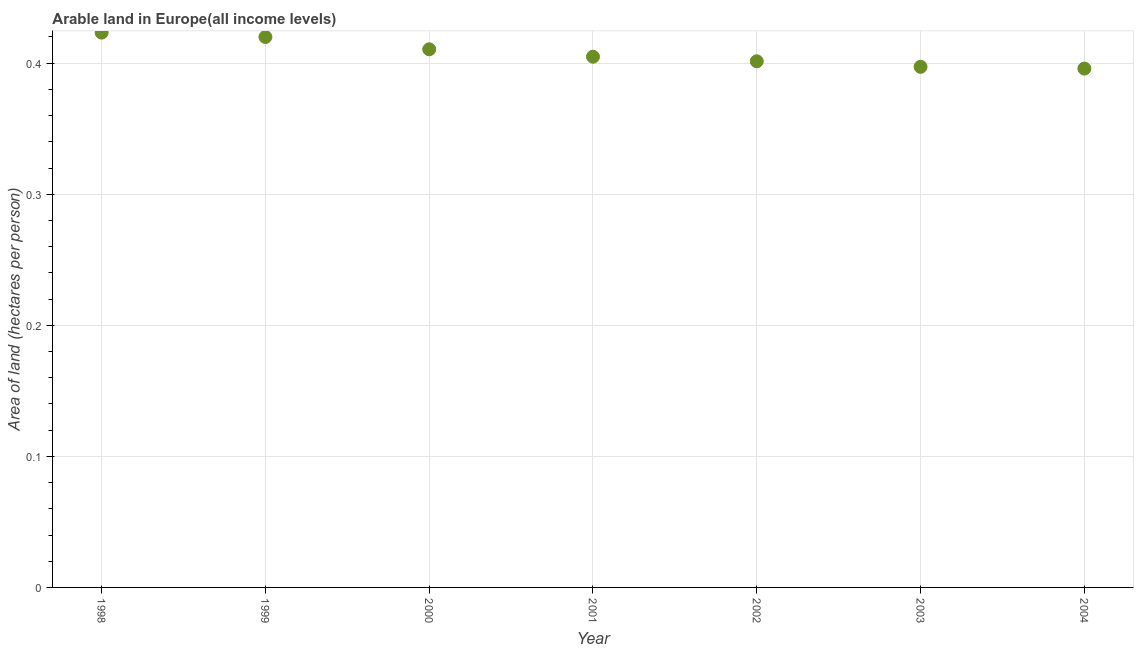What is the area of arable land in 2003?
Provide a succinct answer. 0.4. Across all years, what is the maximum area of arable land?
Keep it short and to the point. 0.42. Across all years, what is the minimum area of arable land?
Provide a short and direct response. 0.4. In which year was the area of arable land maximum?
Offer a terse response. 1998. What is the sum of the area of arable land?
Provide a short and direct response. 2.85. What is the difference between the area of arable land in 1998 and 2001?
Provide a succinct answer. 0.02. What is the average area of arable land per year?
Keep it short and to the point. 0.41. What is the median area of arable land?
Offer a terse response. 0.4. In how many years, is the area of arable land greater than 0.36000000000000004 hectares per person?
Offer a very short reply. 7. Do a majority of the years between 1999 and 2000 (inclusive) have area of arable land greater than 0.36000000000000004 hectares per person?
Make the answer very short. Yes. What is the ratio of the area of arable land in 1999 to that in 2000?
Ensure brevity in your answer.  1.02. Is the difference between the area of arable land in 2001 and 2004 greater than the difference between any two years?
Your answer should be compact. No. What is the difference between the highest and the second highest area of arable land?
Offer a terse response. 0. Is the sum of the area of arable land in 1999 and 2000 greater than the maximum area of arable land across all years?
Give a very brief answer. Yes. What is the difference between the highest and the lowest area of arable land?
Your response must be concise. 0.03. In how many years, is the area of arable land greater than the average area of arable land taken over all years?
Ensure brevity in your answer.  3. Does the area of arable land monotonically increase over the years?
Your response must be concise. No. What is the difference between two consecutive major ticks on the Y-axis?
Provide a succinct answer. 0.1. Are the values on the major ticks of Y-axis written in scientific E-notation?
Provide a succinct answer. No. Does the graph contain any zero values?
Your answer should be very brief. No. What is the title of the graph?
Your answer should be compact. Arable land in Europe(all income levels). What is the label or title of the Y-axis?
Provide a succinct answer. Area of land (hectares per person). What is the Area of land (hectares per person) in 1998?
Ensure brevity in your answer.  0.42. What is the Area of land (hectares per person) in 1999?
Your response must be concise. 0.42. What is the Area of land (hectares per person) in 2000?
Make the answer very short. 0.41. What is the Area of land (hectares per person) in 2001?
Offer a very short reply. 0.4. What is the Area of land (hectares per person) in 2002?
Provide a succinct answer. 0.4. What is the Area of land (hectares per person) in 2003?
Give a very brief answer. 0.4. What is the Area of land (hectares per person) in 2004?
Give a very brief answer. 0.4. What is the difference between the Area of land (hectares per person) in 1998 and 1999?
Provide a succinct answer. 0. What is the difference between the Area of land (hectares per person) in 1998 and 2000?
Your answer should be very brief. 0.01. What is the difference between the Area of land (hectares per person) in 1998 and 2001?
Offer a terse response. 0.02. What is the difference between the Area of land (hectares per person) in 1998 and 2002?
Ensure brevity in your answer.  0.02. What is the difference between the Area of land (hectares per person) in 1998 and 2003?
Give a very brief answer. 0.03. What is the difference between the Area of land (hectares per person) in 1998 and 2004?
Your answer should be very brief. 0.03. What is the difference between the Area of land (hectares per person) in 1999 and 2000?
Ensure brevity in your answer.  0.01. What is the difference between the Area of land (hectares per person) in 1999 and 2001?
Your answer should be compact. 0.02. What is the difference between the Area of land (hectares per person) in 1999 and 2002?
Give a very brief answer. 0.02. What is the difference between the Area of land (hectares per person) in 1999 and 2003?
Offer a terse response. 0.02. What is the difference between the Area of land (hectares per person) in 1999 and 2004?
Offer a very short reply. 0.02. What is the difference between the Area of land (hectares per person) in 2000 and 2001?
Offer a terse response. 0.01. What is the difference between the Area of land (hectares per person) in 2000 and 2002?
Make the answer very short. 0.01. What is the difference between the Area of land (hectares per person) in 2000 and 2003?
Make the answer very short. 0.01. What is the difference between the Area of land (hectares per person) in 2000 and 2004?
Offer a very short reply. 0.01. What is the difference between the Area of land (hectares per person) in 2001 and 2002?
Your answer should be compact. 0. What is the difference between the Area of land (hectares per person) in 2001 and 2003?
Make the answer very short. 0.01. What is the difference between the Area of land (hectares per person) in 2001 and 2004?
Make the answer very short. 0.01. What is the difference between the Area of land (hectares per person) in 2002 and 2003?
Provide a short and direct response. 0. What is the difference between the Area of land (hectares per person) in 2002 and 2004?
Offer a very short reply. 0.01. What is the difference between the Area of land (hectares per person) in 2003 and 2004?
Your response must be concise. 0. What is the ratio of the Area of land (hectares per person) in 1998 to that in 2000?
Your answer should be very brief. 1.03. What is the ratio of the Area of land (hectares per person) in 1998 to that in 2001?
Provide a short and direct response. 1.04. What is the ratio of the Area of land (hectares per person) in 1998 to that in 2002?
Your answer should be very brief. 1.05. What is the ratio of the Area of land (hectares per person) in 1998 to that in 2003?
Keep it short and to the point. 1.07. What is the ratio of the Area of land (hectares per person) in 1998 to that in 2004?
Your response must be concise. 1.07. What is the ratio of the Area of land (hectares per person) in 1999 to that in 2002?
Provide a short and direct response. 1.05. What is the ratio of the Area of land (hectares per person) in 1999 to that in 2003?
Your response must be concise. 1.06. What is the ratio of the Area of land (hectares per person) in 1999 to that in 2004?
Your answer should be very brief. 1.06. What is the ratio of the Area of land (hectares per person) in 2000 to that in 2002?
Ensure brevity in your answer.  1.02. What is the ratio of the Area of land (hectares per person) in 2000 to that in 2003?
Your answer should be very brief. 1.03. What is the ratio of the Area of land (hectares per person) in 2000 to that in 2004?
Give a very brief answer. 1.04. What is the ratio of the Area of land (hectares per person) in 2001 to that in 2003?
Provide a succinct answer. 1.02. What is the ratio of the Area of land (hectares per person) in 2001 to that in 2004?
Your answer should be very brief. 1.02. What is the ratio of the Area of land (hectares per person) in 2002 to that in 2003?
Provide a succinct answer. 1.01. What is the ratio of the Area of land (hectares per person) in 2002 to that in 2004?
Keep it short and to the point. 1.01. 